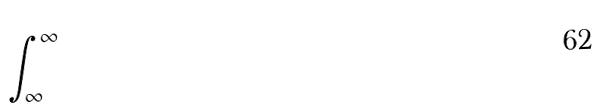Convert formula to latex. <formula><loc_0><loc_0><loc_500><loc_500>\int _ { \infty } ^ { \infty }</formula> 